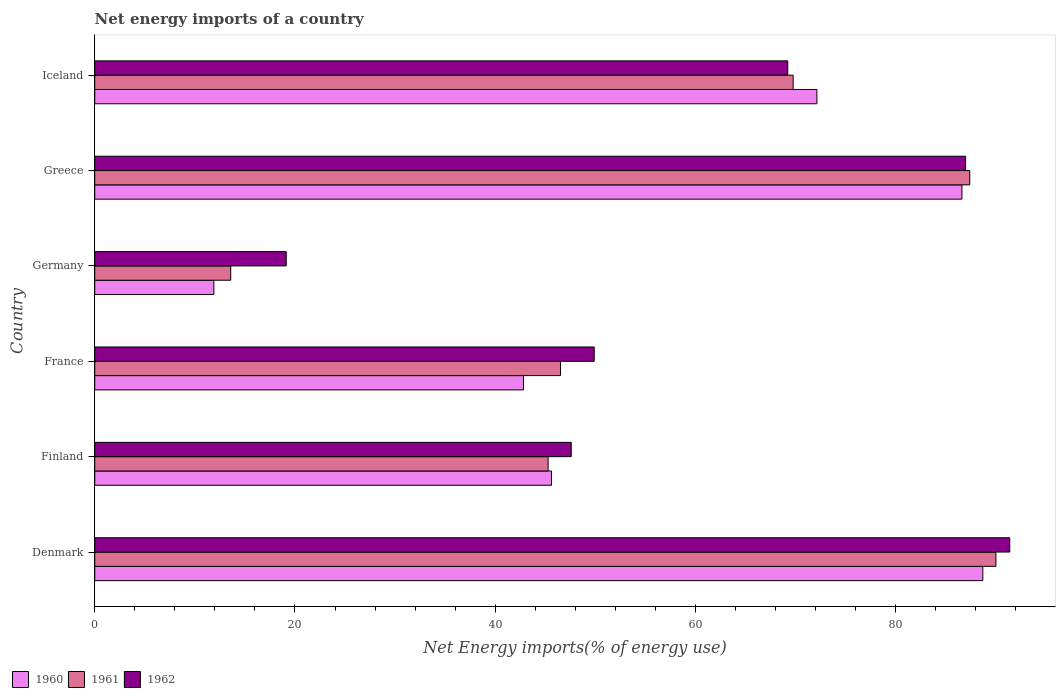How many different coloured bars are there?
Ensure brevity in your answer.  3. How many groups of bars are there?
Offer a very short reply. 6. Are the number of bars per tick equal to the number of legend labels?
Keep it short and to the point. Yes. What is the label of the 4th group of bars from the top?
Provide a short and direct response. France. In how many cases, is the number of bars for a given country not equal to the number of legend labels?
Keep it short and to the point. 0. What is the net energy imports in 1961 in Denmark?
Your answer should be very brief. 90.01. Across all countries, what is the maximum net energy imports in 1961?
Ensure brevity in your answer.  90.01. Across all countries, what is the minimum net energy imports in 1962?
Offer a terse response. 19.13. What is the total net energy imports in 1961 in the graph?
Your response must be concise. 352.54. What is the difference between the net energy imports in 1960 in Denmark and that in Iceland?
Give a very brief answer. 16.57. What is the difference between the net energy imports in 1960 in Denmark and the net energy imports in 1962 in Finland?
Provide a short and direct response. 41.11. What is the average net energy imports in 1962 per country?
Your answer should be very brief. 60.7. What is the difference between the net energy imports in 1962 and net energy imports in 1960 in France?
Provide a succinct answer. 7.06. What is the ratio of the net energy imports in 1961 in France to that in Germany?
Give a very brief answer. 3.43. What is the difference between the highest and the second highest net energy imports in 1962?
Give a very brief answer. 4.41. What is the difference between the highest and the lowest net energy imports in 1962?
Give a very brief answer. 72.26. In how many countries, is the net energy imports in 1961 greater than the average net energy imports in 1961 taken over all countries?
Provide a short and direct response. 3. Is the sum of the net energy imports in 1962 in Finland and Iceland greater than the maximum net energy imports in 1960 across all countries?
Ensure brevity in your answer.  Yes. What does the 1st bar from the top in France represents?
Keep it short and to the point. 1962. What is the difference between two consecutive major ticks on the X-axis?
Your answer should be very brief. 20. Does the graph contain any zero values?
Provide a succinct answer. No. Does the graph contain grids?
Make the answer very short. No. How many legend labels are there?
Keep it short and to the point. 3. How are the legend labels stacked?
Your answer should be very brief. Horizontal. What is the title of the graph?
Make the answer very short. Net energy imports of a country. What is the label or title of the X-axis?
Your answer should be compact. Net Energy imports(% of energy use). What is the Net Energy imports(% of energy use) in 1960 in Denmark?
Keep it short and to the point. 88.7. What is the Net Energy imports(% of energy use) in 1961 in Denmark?
Provide a succinct answer. 90.01. What is the Net Energy imports(% of energy use) in 1962 in Denmark?
Make the answer very short. 91.39. What is the Net Energy imports(% of energy use) of 1960 in Finland?
Your answer should be very brief. 45.62. What is the Net Energy imports(% of energy use) in 1961 in Finland?
Your answer should be very brief. 45.28. What is the Net Energy imports(% of energy use) in 1962 in Finland?
Make the answer very short. 47.59. What is the Net Energy imports(% of energy use) of 1960 in France?
Make the answer very short. 42.82. What is the Net Energy imports(% of energy use) of 1961 in France?
Provide a short and direct response. 46.52. What is the Net Energy imports(% of energy use) in 1962 in France?
Give a very brief answer. 49.89. What is the Net Energy imports(% of energy use) of 1960 in Germany?
Offer a very short reply. 11.9. What is the Net Energy imports(% of energy use) of 1961 in Germany?
Your answer should be very brief. 13.58. What is the Net Energy imports(% of energy use) of 1962 in Germany?
Keep it short and to the point. 19.13. What is the Net Energy imports(% of energy use) in 1960 in Greece?
Make the answer very short. 86.62. What is the Net Energy imports(% of energy use) in 1961 in Greece?
Give a very brief answer. 87.4. What is the Net Energy imports(% of energy use) of 1962 in Greece?
Your answer should be compact. 86.98. What is the Net Energy imports(% of energy use) of 1960 in Iceland?
Offer a very short reply. 72.13. What is the Net Energy imports(% of energy use) in 1961 in Iceland?
Provide a succinct answer. 69.76. What is the Net Energy imports(% of energy use) of 1962 in Iceland?
Your response must be concise. 69.22. Across all countries, what is the maximum Net Energy imports(% of energy use) of 1960?
Keep it short and to the point. 88.7. Across all countries, what is the maximum Net Energy imports(% of energy use) in 1961?
Offer a terse response. 90.01. Across all countries, what is the maximum Net Energy imports(% of energy use) of 1962?
Your answer should be very brief. 91.39. Across all countries, what is the minimum Net Energy imports(% of energy use) of 1960?
Your response must be concise. 11.9. Across all countries, what is the minimum Net Energy imports(% of energy use) in 1961?
Ensure brevity in your answer.  13.58. Across all countries, what is the minimum Net Energy imports(% of energy use) of 1962?
Keep it short and to the point. 19.13. What is the total Net Energy imports(% of energy use) of 1960 in the graph?
Offer a terse response. 347.79. What is the total Net Energy imports(% of energy use) of 1961 in the graph?
Ensure brevity in your answer.  352.54. What is the total Net Energy imports(% of energy use) of 1962 in the graph?
Give a very brief answer. 364.19. What is the difference between the Net Energy imports(% of energy use) of 1960 in Denmark and that in Finland?
Give a very brief answer. 43.08. What is the difference between the Net Energy imports(% of energy use) of 1961 in Denmark and that in Finland?
Ensure brevity in your answer.  44.73. What is the difference between the Net Energy imports(% of energy use) of 1962 in Denmark and that in Finland?
Offer a very short reply. 43.8. What is the difference between the Net Energy imports(% of energy use) of 1960 in Denmark and that in France?
Your answer should be compact. 45.88. What is the difference between the Net Energy imports(% of energy use) in 1961 in Denmark and that in France?
Offer a very short reply. 43.49. What is the difference between the Net Energy imports(% of energy use) of 1962 in Denmark and that in France?
Your response must be concise. 41.5. What is the difference between the Net Energy imports(% of energy use) in 1960 in Denmark and that in Germany?
Ensure brevity in your answer.  76.8. What is the difference between the Net Energy imports(% of energy use) of 1961 in Denmark and that in Germany?
Make the answer very short. 76.43. What is the difference between the Net Energy imports(% of energy use) in 1962 in Denmark and that in Germany?
Provide a short and direct response. 72.26. What is the difference between the Net Energy imports(% of energy use) in 1960 in Denmark and that in Greece?
Your answer should be very brief. 2.09. What is the difference between the Net Energy imports(% of energy use) in 1961 in Denmark and that in Greece?
Offer a very short reply. 2.61. What is the difference between the Net Energy imports(% of energy use) in 1962 in Denmark and that in Greece?
Provide a succinct answer. 4.41. What is the difference between the Net Energy imports(% of energy use) in 1960 in Denmark and that in Iceland?
Keep it short and to the point. 16.57. What is the difference between the Net Energy imports(% of energy use) in 1961 in Denmark and that in Iceland?
Ensure brevity in your answer.  20.25. What is the difference between the Net Energy imports(% of energy use) of 1962 in Denmark and that in Iceland?
Your answer should be very brief. 22.17. What is the difference between the Net Energy imports(% of energy use) in 1960 in Finland and that in France?
Your answer should be compact. 2.8. What is the difference between the Net Energy imports(% of energy use) in 1961 in Finland and that in France?
Offer a very short reply. -1.24. What is the difference between the Net Energy imports(% of energy use) in 1962 in Finland and that in France?
Give a very brief answer. -2.3. What is the difference between the Net Energy imports(% of energy use) in 1960 in Finland and that in Germany?
Ensure brevity in your answer.  33.72. What is the difference between the Net Energy imports(% of energy use) of 1961 in Finland and that in Germany?
Your response must be concise. 31.7. What is the difference between the Net Energy imports(% of energy use) of 1962 in Finland and that in Germany?
Your answer should be compact. 28.47. What is the difference between the Net Energy imports(% of energy use) of 1960 in Finland and that in Greece?
Provide a short and direct response. -41. What is the difference between the Net Energy imports(% of energy use) in 1961 in Finland and that in Greece?
Make the answer very short. -42.12. What is the difference between the Net Energy imports(% of energy use) in 1962 in Finland and that in Greece?
Offer a very short reply. -39.39. What is the difference between the Net Energy imports(% of energy use) in 1960 in Finland and that in Iceland?
Give a very brief answer. -26.51. What is the difference between the Net Energy imports(% of energy use) of 1961 in Finland and that in Iceland?
Give a very brief answer. -24.48. What is the difference between the Net Energy imports(% of energy use) in 1962 in Finland and that in Iceland?
Offer a terse response. -21.63. What is the difference between the Net Energy imports(% of energy use) in 1960 in France and that in Germany?
Offer a very short reply. 30.93. What is the difference between the Net Energy imports(% of energy use) in 1961 in France and that in Germany?
Offer a very short reply. 32.94. What is the difference between the Net Energy imports(% of energy use) of 1962 in France and that in Germany?
Provide a short and direct response. 30.76. What is the difference between the Net Energy imports(% of energy use) of 1960 in France and that in Greece?
Give a very brief answer. -43.79. What is the difference between the Net Energy imports(% of energy use) in 1961 in France and that in Greece?
Your answer should be very brief. -40.87. What is the difference between the Net Energy imports(% of energy use) in 1962 in France and that in Greece?
Give a very brief answer. -37.09. What is the difference between the Net Energy imports(% of energy use) of 1960 in France and that in Iceland?
Provide a succinct answer. -29.3. What is the difference between the Net Energy imports(% of energy use) in 1961 in France and that in Iceland?
Your answer should be very brief. -23.24. What is the difference between the Net Energy imports(% of energy use) in 1962 in France and that in Iceland?
Provide a succinct answer. -19.33. What is the difference between the Net Energy imports(% of energy use) of 1960 in Germany and that in Greece?
Give a very brief answer. -74.72. What is the difference between the Net Energy imports(% of energy use) in 1961 in Germany and that in Greece?
Your answer should be very brief. -73.81. What is the difference between the Net Energy imports(% of energy use) in 1962 in Germany and that in Greece?
Give a very brief answer. -67.86. What is the difference between the Net Energy imports(% of energy use) in 1960 in Germany and that in Iceland?
Provide a short and direct response. -60.23. What is the difference between the Net Energy imports(% of energy use) in 1961 in Germany and that in Iceland?
Your response must be concise. -56.17. What is the difference between the Net Energy imports(% of energy use) in 1962 in Germany and that in Iceland?
Offer a terse response. -50.09. What is the difference between the Net Energy imports(% of energy use) of 1960 in Greece and that in Iceland?
Provide a succinct answer. 14.49. What is the difference between the Net Energy imports(% of energy use) in 1961 in Greece and that in Iceland?
Ensure brevity in your answer.  17.64. What is the difference between the Net Energy imports(% of energy use) in 1962 in Greece and that in Iceland?
Offer a very short reply. 17.77. What is the difference between the Net Energy imports(% of energy use) in 1960 in Denmark and the Net Energy imports(% of energy use) in 1961 in Finland?
Ensure brevity in your answer.  43.42. What is the difference between the Net Energy imports(% of energy use) in 1960 in Denmark and the Net Energy imports(% of energy use) in 1962 in Finland?
Offer a very short reply. 41.11. What is the difference between the Net Energy imports(% of energy use) of 1961 in Denmark and the Net Energy imports(% of energy use) of 1962 in Finland?
Provide a succinct answer. 42.42. What is the difference between the Net Energy imports(% of energy use) in 1960 in Denmark and the Net Energy imports(% of energy use) in 1961 in France?
Give a very brief answer. 42.18. What is the difference between the Net Energy imports(% of energy use) in 1960 in Denmark and the Net Energy imports(% of energy use) in 1962 in France?
Keep it short and to the point. 38.81. What is the difference between the Net Energy imports(% of energy use) of 1961 in Denmark and the Net Energy imports(% of energy use) of 1962 in France?
Your answer should be compact. 40.12. What is the difference between the Net Energy imports(% of energy use) of 1960 in Denmark and the Net Energy imports(% of energy use) of 1961 in Germany?
Provide a succinct answer. 75.12. What is the difference between the Net Energy imports(% of energy use) in 1960 in Denmark and the Net Energy imports(% of energy use) in 1962 in Germany?
Ensure brevity in your answer.  69.58. What is the difference between the Net Energy imports(% of energy use) of 1961 in Denmark and the Net Energy imports(% of energy use) of 1962 in Germany?
Your answer should be compact. 70.88. What is the difference between the Net Energy imports(% of energy use) of 1960 in Denmark and the Net Energy imports(% of energy use) of 1961 in Greece?
Ensure brevity in your answer.  1.31. What is the difference between the Net Energy imports(% of energy use) of 1960 in Denmark and the Net Energy imports(% of energy use) of 1962 in Greece?
Offer a terse response. 1.72. What is the difference between the Net Energy imports(% of energy use) in 1961 in Denmark and the Net Energy imports(% of energy use) in 1962 in Greece?
Provide a short and direct response. 3.03. What is the difference between the Net Energy imports(% of energy use) in 1960 in Denmark and the Net Energy imports(% of energy use) in 1961 in Iceland?
Your answer should be compact. 18.94. What is the difference between the Net Energy imports(% of energy use) in 1960 in Denmark and the Net Energy imports(% of energy use) in 1962 in Iceland?
Offer a very short reply. 19.48. What is the difference between the Net Energy imports(% of energy use) in 1961 in Denmark and the Net Energy imports(% of energy use) in 1962 in Iceland?
Give a very brief answer. 20.79. What is the difference between the Net Energy imports(% of energy use) of 1960 in Finland and the Net Energy imports(% of energy use) of 1961 in France?
Your answer should be compact. -0.9. What is the difference between the Net Energy imports(% of energy use) of 1960 in Finland and the Net Energy imports(% of energy use) of 1962 in France?
Keep it short and to the point. -4.27. What is the difference between the Net Energy imports(% of energy use) in 1961 in Finland and the Net Energy imports(% of energy use) in 1962 in France?
Your response must be concise. -4.61. What is the difference between the Net Energy imports(% of energy use) in 1960 in Finland and the Net Energy imports(% of energy use) in 1961 in Germany?
Ensure brevity in your answer.  32.04. What is the difference between the Net Energy imports(% of energy use) in 1960 in Finland and the Net Energy imports(% of energy use) in 1962 in Germany?
Provide a succinct answer. 26.49. What is the difference between the Net Energy imports(% of energy use) in 1961 in Finland and the Net Energy imports(% of energy use) in 1962 in Germany?
Provide a short and direct response. 26.15. What is the difference between the Net Energy imports(% of energy use) in 1960 in Finland and the Net Energy imports(% of energy use) in 1961 in Greece?
Offer a terse response. -41.78. What is the difference between the Net Energy imports(% of energy use) in 1960 in Finland and the Net Energy imports(% of energy use) in 1962 in Greece?
Offer a very short reply. -41.36. What is the difference between the Net Energy imports(% of energy use) of 1961 in Finland and the Net Energy imports(% of energy use) of 1962 in Greece?
Your response must be concise. -41.7. What is the difference between the Net Energy imports(% of energy use) of 1960 in Finland and the Net Energy imports(% of energy use) of 1961 in Iceland?
Provide a succinct answer. -24.14. What is the difference between the Net Energy imports(% of energy use) in 1960 in Finland and the Net Energy imports(% of energy use) in 1962 in Iceland?
Give a very brief answer. -23.6. What is the difference between the Net Energy imports(% of energy use) of 1961 in Finland and the Net Energy imports(% of energy use) of 1962 in Iceland?
Give a very brief answer. -23.94. What is the difference between the Net Energy imports(% of energy use) of 1960 in France and the Net Energy imports(% of energy use) of 1961 in Germany?
Ensure brevity in your answer.  29.24. What is the difference between the Net Energy imports(% of energy use) in 1960 in France and the Net Energy imports(% of energy use) in 1962 in Germany?
Provide a short and direct response. 23.7. What is the difference between the Net Energy imports(% of energy use) in 1961 in France and the Net Energy imports(% of energy use) in 1962 in Germany?
Provide a succinct answer. 27.39. What is the difference between the Net Energy imports(% of energy use) of 1960 in France and the Net Energy imports(% of energy use) of 1961 in Greece?
Make the answer very short. -44.57. What is the difference between the Net Energy imports(% of energy use) in 1960 in France and the Net Energy imports(% of energy use) in 1962 in Greece?
Your answer should be compact. -44.16. What is the difference between the Net Energy imports(% of energy use) in 1961 in France and the Net Energy imports(% of energy use) in 1962 in Greece?
Keep it short and to the point. -40.46. What is the difference between the Net Energy imports(% of energy use) in 1960 in France and the Net Energy imports(% of energy use) in 1961 in Iceland?
Offer a very short reply. -26.93. What is the difference between the Net Energy imports(% of energy use) of 1960 in France and the Net Energy imports(% of energy use) of 1962 in Iceland?
Provide a succinct answer. -26.39. What is the difference between the Net Energy imports(% of energy use) in 1961 in France and the Net Energy imports(% of energy use) in 1962 in Iceland?
Offer a terse response. -22.7. What is the difference between the Net Energy imports(% of energy use) of 1960 in Germany and the Net Energy imports(% of energy use) of 1961 in Greece?
Your response must be concise. -75.5. What is the difference between the Net Energy imports(% of energy use) of 1960 in Germany and the Net Energy imports(% of energy use) of 1962 in Greece?
Your response must be concise. -75.08. What is the difference between the Net Energy imports(% of energy use) in 1961 in Germany and the Net Energy imports(% of energy use) in 1962 in Greece?
Your answer should be compact. -73.4. What is the difference between the Net Energy imports(% of energy use) of 1960 in Germany and the Net Energy imports(% of energy use) of 1961 in Iceland?
Your answer should be very brief. -57.86. What is the difference between the Net Energy imports(% of energy use) of 1960 in Germany and the Net Energy imports(% of energy use) of 1962 in Iceland?
Your answer should be very brief. -57.32. What is the difference between the Net Energy imports(% of energy use) of 1961 in Germany and the Net Energy imports(% of energy use) of 1962 in Iceland?
Your answer should be compact. -55.63. What is the difference between the Net Energy imports(% of energy use) in 1960 in Greece and the Net Energy imports(% of energy use) in 1961 in Iceland?
Your response must be concise. 16.86. What is the difference between the Net Energy imports(% of energy use) of 1960 in Greece and the Net Energy imports(% of energy use) of 1962 in Iceland?
Provide a succinct answer. 17.4. What is the difference between the Net Energy imports(% of energy use) of 1961 in Greece and the Net Energy imports(% of energy use) of 1962 in Iceland?
Offer a terse response. 18.18. What is the average Net Energy imports(% of energy use) of 1960 per country?
Your answer should be compact. 57.96. What is the average Net Energy imports(% of energy use) in 1961 per country?
Your answer should be compact. 58.76. What is the average Net Energy imports(% of energy use) of 1962 per country?
Your answer should be compact. 60.7. What is the difference between the Net Energy imports(% of energy use) in 1960 and Net Energy imports(% of energy use) in 1961 in Denmark?
Your response must be concise. -1.31. What is the difference between the Net Energy imports(% of energy use) of 1960 and Net Energy imports(% of energy use) of 1962 in Denmark?
Provide a short and direct response. -2.69. What is the difference between the Net Energy imports(% of energy use) of 1961 and Net Energy imports(% of energy use) of 1962 in Denmark?
Make the answer very short. -1.38. What is the difference between the Net Energy imports(% of energy use) of 1960 and Net Energy imports(% of energy use) of 1961 in Finland?
Ensure brevity in your answer.  0.34. What is the difference between the Net Energy imports(% of energy use) in 1960 and Net Energy imports(% of energy use) in 1962 in Finland?
Offer a very short reply. -1.97. What is the difference between the Net Energy imports(% of energy use) in 1961 and Net Energy imports(% of energy use) in 1962 in Finland?
Your response must be concise. -2.31. What is the difference between the Net Energy imports(% of energy use) of 1960 and Net Energy imports(% of energy use) of 1961 in France?
Your answer should be very brief. -3.7. What is the difference between the Net Energy imports(% of energy use) in 1960 and Net Energy imports(% of energy use) in 1962 in France?
Offer a very short reply. -7.06. What is the difference between the Net Energy imports(% of energy use) of 1961 and Net Energy imports(% of energy use) of 1962 in France?
Your response must be concise. -3.37. What is the difference between the Net Energy imports(% of energy use) in 1960 and Net Energy imports(% of energy use) in 1961 in Germany?
Provide a short and direct response. -1.68. What is the difference between the Net Energy imports(% of energy use) of 1960 and Net Energy imports(% of energy use) of 1962 in Germany?
Offer a very short reply. -7.23. What is the difference between the Net Energy imports(% of energy use) in 1961 and Net Energy imports(% of energy use) in 1962 in Germany?
Provide a short and direct response. -5.54. What is the difference between the Net Energy imports(% of energy use) in 1960 and Net Energy imports(% of energy use) in 1961 in Greece?
Make the answer very short. -0.78. What is the difference between the Net Energy imports(% of energy use) in 1960 and Net Energy imports(% of energy use) in 1962 in Greece?
Provide a succinct answer. -0.37. What is the difference between the Net Energy imports(% of energy use) of 1961 and Net Energy imports(% of energy use) of 1962 in Greece?
Ensure brevity in your answer.  0.41. What is the difference between the Net Energy imports(% of energy use) in 1960 and Net Energy imports(% of energy use) in 1961 in Iceland?
Your answer should be compact. 2.37. What is the difference between the Net Energy imports(% of energy use) in 1960 and Net Energy imports(% of energy use) in 1962 in Iceland?
Give a very brief answer. 2.91. What is the difference between the Net Energy imports(% of energy use) in 1961 and Net Energy imports(% of energy use) in 1962 in Iceland?
Make the answer very short. 0.54. What is the ratio of the Net Energy imports(% of energy use) in 1960 in Denmark to that in Finland?
Offer a very short reply. 1.94. What is the ratio of the Net Energy imports(% of energy use) of 1961 in Denmark to that in Finland?
Your response must be concise. 1.99. What is the ratio of the Net Energy imports(% of energy use) in 1962 in Denmark to that in Finland?
Your response must be concise. 1.92. What is the ratio of the Net Energy imports(% of energy use) of 1960 in Denmark to that in France?
Offer a very short reply. 2.07. What is the ratio of the Net Energy imports(% of energy use) in 1961 in Denmark to that in France?
Provide a succinct answer. 1.93. What is the ratio of the Net Energy imports(% of energy use) of 1962 in Denmark to that in France?
Keep it short and to the point. 1.83. What is the ratio of the Net Energy imports(% of energy use) of 1960 in Denmark to that in Germany?
Make the answer very short. 7.46. What is the ratio of the Net Energy imports(% of energy use) of 1961 in Denmark to that in Germany?
Offer a very short reply. 6.63. What is the ratio of the Net Energy imports(% of energy use) of 1962 in Denmark to that in Germany?
Your answer should be compact. 4.78. What is the ratio of the Net Energy imports(% of energy use) of 1960 in Denmark to that in Greece?
Keep it short and to the point. 1.02. What is the ratio of the Net Energy imports(% of energy use) of 1961 in Denmark to that in Greece?
Your answer should be compact. 1.03. What is the ratio of the Net Energy imports(% of energy use) in 1962 in Denmark to that in Greece?
Your answer should be very brief. 1.05. What is the ratio of the Net Energy imports(% of energy use) of 1960 in Denmark to that in Iceland?
Make the answer very short. 1.23. What is the ratio of the Net Energy imports(% of energy use) of 1961 in Denmark to that in Iceland?
Give a very brief answer. 1.29. What is the ratio of the Net Energy imports(% of energy use) of 1962 in Denmark to that in Iceland?
Your response must be concise. 1.32. What is the ratio of the Net Energy imports(% of energy use) of 1960 in Finland to that in France?
Offer a very short reply. 1.07. What is the ratio of the Net Energy imports(% of energy use) of 1961 in Finland to that in France?
Provide a short and direct response. 0.97. What is the ratio of the Net Energy imports(% of energy use) of 1962 in Finland to that in France?
Your answer should be very brief. 0.95. What is the ratio of the Net Energy imports(% of energy use) in 1960 in Finland to that in Germany?
Keep it short and to the point. 3.83. What is the ratio of the Net Energy imports(% of energy use) in 1961 in Finland to that in Germany?
Provide a short and direct response. 3.33. What is the ratio of the Net Energy imports(% of energy use) of 1962 in Finland to that in Germany?
Make the answer very short. 2.49. What is the ratio of the Net Energy imports(% of energy use) in 1960 in Finland to that in Greece?
Make the answer very short. 0.53. What is the ratio of the Net Energy imports(% of energy use) of 1961 in Finland to that in Greece?
Make the answer very short. 0.52. What is the ratio of the Net Energy imports(% of energy use) in 1962 in Finland to that in Greece?
Offer a terse response. 0.55. What is the ratio of the Net Energy imports(% of energy use) of 1960 in Finland to that in Iceland?
Give a very brief answer. 0.63. What is the ratio of the Net Energy imports(% of energy use) of 1961 in Finland to that in Iceland?
Give a very brief answer. 0.65. What is the ratio of the Net Energy imports(% of energy use) of 1962 in Finland to that in Iceland?
Your answer should be very brief. 0.69. What is the ratio of the Net Energy imports(% of energy use) of 1960 in France to that in Germany?
Make the answer very short. 3.6. What is the ratio of the Net Energy imports(% of energy use) of 1961 in France to that in Germany?
Offer a very short reply. 3.43. What is the ratio of the Net Energy imports(% of energy use) in 1962 in France to that in Germany?
Make the answer very short. 2.61. What is the ratio of the Net Energy imports(% of energy use) in 1960 in France to that in Greece?
Your answer should be very brief. 0.49. What is the ratio of the Net Energy imports(% of energy use) of 1961 in France to that in Greece?
Your answer should be very brief. 0.53. What is the ratio of the Net Energy imports(% of energy use) of 1962 in France to that in Greece?
Offer a terse response. 0.57. What is the ratio of the Net Energy imports(% of energy use) in 1960 in France to that in Iceland?
Offer a very short reply. 0.59. What is the ratio of the Net Energy imports(% of energy use) in 1961 in France to that in Iceland?
Provide a succinct answer. 0.67. What is the ratio of the Net Energy imports(% of energy use) in 1962 in France to that in Iceland?
Give a very brief answer. 0.72. What is the ratio of the Net Energy imports(% of energy use) of 1960 in Germany to that in Greece?
Keep it short and to the point. 0.14. What is the ratio of the Net Energy imports(% of energy use) of 1961 in Germany to that in Greece?
Provide a short and direct response. 0.16. What is the ratio of the Net Energy imports(% of energy use) in 1962 in Germany to that in Greece?
Provide a succinct answer. 0.22. What is the ratio of the Net Energy imports(% of energy use) of 1960 in Germany to that in Iceland?
Offer a very short reply. 0.17. What is the ratio of the Net Energy imports(% of energy use) of 1961 in Germany to that in Iceland?
Ensure brevity in your answer.  0.19. What is the ratio of the Net Energy imports(% of energy use) of 1962 in Germany to that in Iceland?
Make the answer very short. 0.28. What is the ratio of the Net Energy imports(% of energy use) of 1960 in Greece to that in Iceland?
Your answer should be compact. 1.2. What is the ratio of the Net Energy imports(% of energy use) in 1961 in Greece to that in Iceland?
Provide a succinct answer. 1.25. What is the ratio of the Net Energy imports(% of energy use) in 1962 in Greece to that in Iceland?
Make the answer very short. 1.26. What is the difference between the highest and the second highest Net Energy imports(% of energy use) in 1960?
Your answer should be compact. 2.09. What is the difference between the highest and the second highest Net Energy imports(% of energy use) of 1961?
Your response must be concise. 2.61. What is the difference between the highest and the second highest Net Energy imports(% of energy use) of 1962?
Offer a terse response. 4.41. What is the difference between the highest and the lowest Net Energy imports(% of energy use) of 1960?
Offer a terse response. 76.8. What is the difference between the highest and the lowest Net Energy imports(% of energy use) of 1961?
Offer a very short reply. 76.43. What is the difference between the highest and the lowest Net Energy imports(% of energy use) of 1962?
Keep it short and to the point. 72.26. 